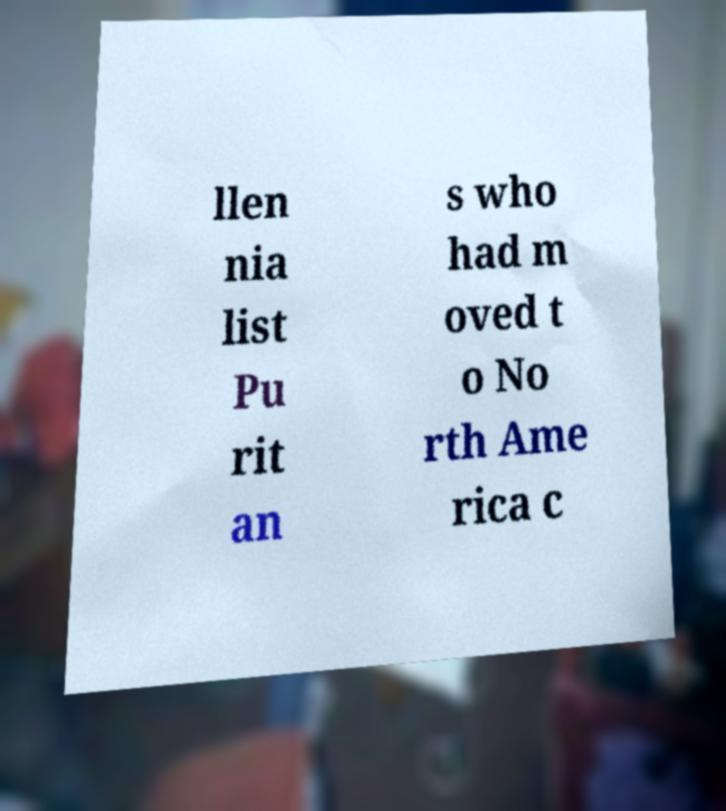Can you accurately transcribe the text from the provided image for me? llen nia list Pu rit an s who had m oved t o No rth Ame rica c 